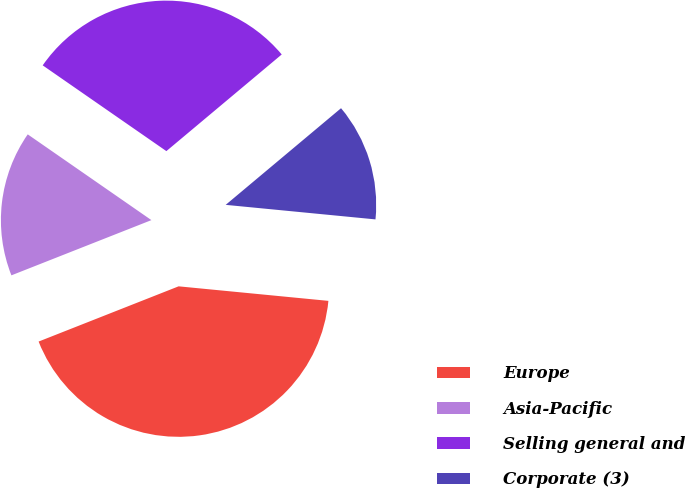Convert chart. <chart><loc_0><loc_0><loc_500><loc_500><pie_chart><fcel>Europe<fcel>Asia-Pacific<fcel>Selling general and<fcel>Corporate (3)<nl><fcel>42.48%<fcel>15.63%<fcel>29.25%<fcel>12.64%<nl></chart> 